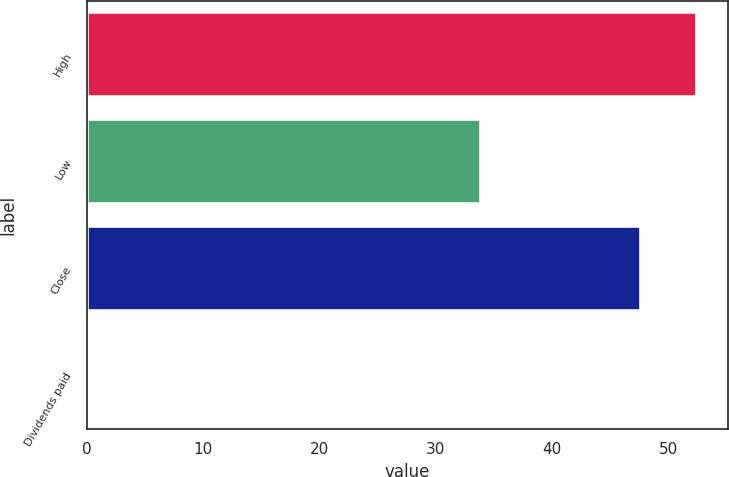Convert chart. <chart><loc_0><loc_0><loc_500><loc_500><bar_chart><fcel>High<fcel>Low<fcel>Close<fcel>Dividends paid<nl><fcel>52.47<fcel>33.88<fcel>47.61<fcel>0.22<nl></chart> 